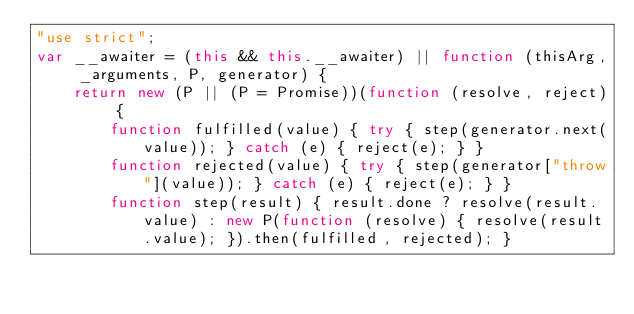<code> <loc_0><loc_0><loc_500><loc_500><_JavaScript_>"use strict";
var __awaiter = (this && this.__awaiter) || function (thisArg, _arguments, P, generator) {
    return new (P || (P = Promise))(function (resolve, reject) {
        function fulfilled(value) { try { step(generator.next(value)); } catch (e) { reject(e); } }
        function rejected(value) { try { step(generator["throw"](value)); } catch (e) { reject(e); } }
        function step(result) { result.done ? resolve(result.value) : new P(function (resolve) { resolve(result.value); }).then(fulfilled, rejected); }</code> 